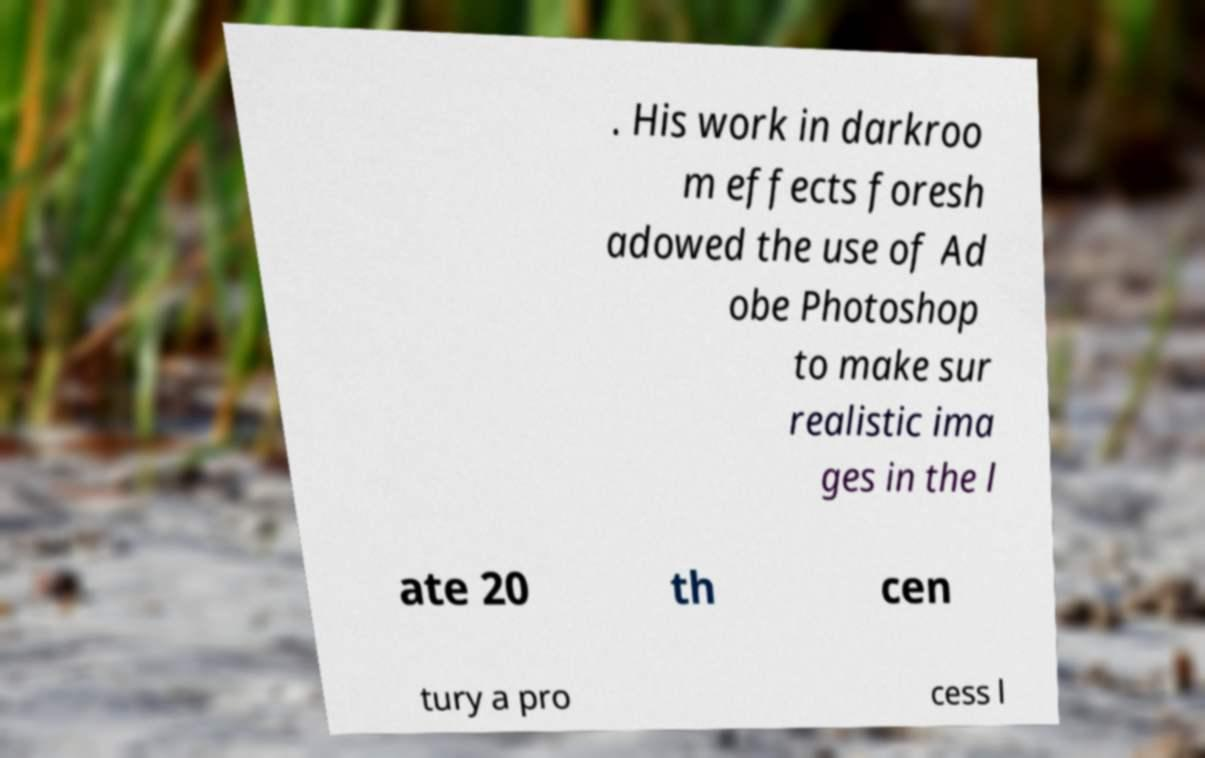Could you extract and type out the text from this image? . His work in darkroo m effects foresh adowed the use of Ad obe Photoshop to make sur realistic ima ges in the l ate 20 th cen tury a pro cess l 